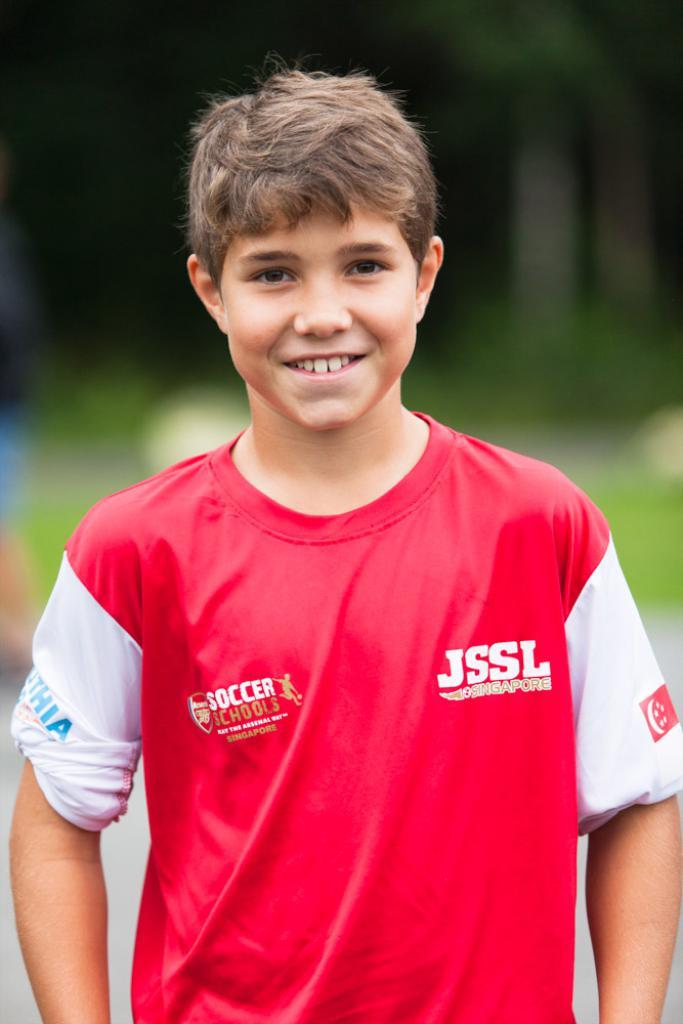What are the initials shown on front right side?
Make the answer very short. Jssl. 